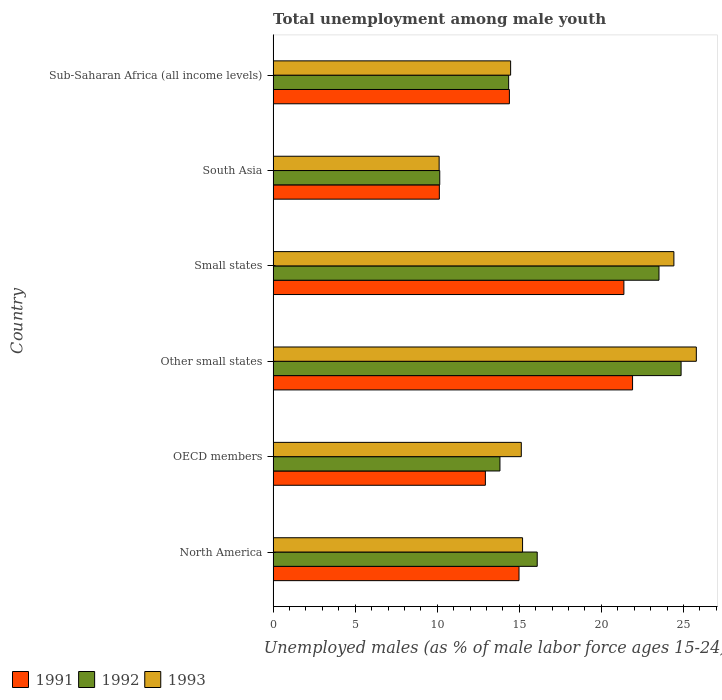How many different coloured bars are there?
Your answer should be very brief. 3. How many groups of bars are there?
Give a very brief answer. 6. How many bars are there on the 3rd tick from the bottom?
Offer a very short reply. 3. What is the label of the 1st group of bars from the top?
Keep it short and to the point. Sub-Saharan Africa (all income levels). What is the percentage of unemployed males in in 1991 in OECD members?
Your response must be concise. 12.93. Across all countries, what is the maximum percentage of unemployed males in in 1993?
Offer a very short reply. 25.79. Across all countries, what is the minimum percentage of unemployed males in in 1993?
Keep it short and to the point. 10.12. In which country was the percentage of unemployed males in in 1991 maximum?
Give a very brief answer. Other small states. In which country was the percentage of unemployed males in in 1991 minimum?
Your answer should be compact. South Asia. What is the total percentage of unemployed males in in 1993 in the graph?
Your answer should be compact. 105.11. What is the difference between the percentage of unemployed males in in 1991 in North America and that in Other small states?
Give a very brief answer. -6.92. What is the difference between the percentage of unemployed males in in 1991 in North America and the percentage of unemployed males in in 1993 in Other small states?
Offer a very short reply. -10.8. What is the average percentage of unemployed males in in 1992 per country?
Your answer should be very brief. 17.13. What is the difference between the percentage of unemployed males in in 1993 and percentage of unemployed males in in 1991 in Sub-Saharan Africa (all income levels)?
Give a very brief answer. 0.08. What is the ratio of the percentage of unemployed males in in 1992 in South Asia to that in Sub-Saharan Africa (all income levels)?
Offer a terse response. 0.71. Is the percentage of unemployed males in in 1993 in OECD members less than that in Small states?
Give a very brief answer. Yes. Is the difference between the percentage of unemployed males in in 1993 in OECD members and Small states greater than the difference between the percentage of unemployed males in in 1991 in OECD members and Small states?
Ensure brevity in your answer.  No. What is the difference between the highest and the second highest percentage of unemployed males in in 1991?
Provide a succinct answer. 0.53. What is the difference between the highest and the lowest percentage of unemployed males in in 1993?
Offer a very short reply. 15.67. In how many countries, is the percentage of unemployed males in in 1991 greater than the average percentage of unemployed males in in 1991 taken over all countries?
Ensure brevity in your answer.  2. How many bars are there?
Give a very brief answer. 18. What is the difference between two consecutive major ticks on the X-axis?
Make the answer very short. 5. How are the legend labels stacked?
Your response must be concise. Horizontal. What is the title of the graph?
Make the answer very short. Total unemployment among male youth. Does "1974" appear as one of the legend labels in the graph?
Give a very brief answer. No. What is the label or title of the X-axis?
Your answer should be compact. Unemployed males (as % of male labor force ages 15-24). What is the label or title of the Y-axis?
Offer a terse response. Country. What is the Unemployed males (as % of male labor force ages 15-24) of 1991 in North America?
Offer a terse response. 14.98. What is the Unemployed males (as % of male labor force ages 15-24) in 1992 in North America?
Offer a very short reply. 16.09. What is the Unemployed males (as % of male labor force ages 15-24) of 1993 in North America?
Offer a terse response. 15.2. What is the Unemployed males (as % of male labor force ages 15-24) in 1991 in OECD members?
Provide a succinct answer. 12.93. What is the Unemployed males (as % of male labor force ages 15-24) of 1992 in OECD members?
Offer a terse response. 13.82. What is the Unemployed males (as % of male labor force ages 15-24) of 1993 in OECD members?
Provide a succinct answer. 15.12. What is the Unemployed males (as % of male labor force ages 15-24) in 1991 in Other small states?
Offer a very short reply. 21.9. What is the Unemployed males (as % of male labor force ages 15-24) of 1992 in Other small states?
Offer a terse response. 24.86. What is the Unemployed males (as % of male labor force ages 15-24) in 1993 in Other small states?
Your answer should be very brief. 25.79. What is the Unemployed males (as % of male labor force ages 15-24) in 1991 in Small states?
Your response must be concise. 21.37. What is the Unemployed males (as % of male labor force ages 15-24) of 1992 in Small states?
Your answer should be compact. 23.51. What is the Unemployed males (as % of male labor force ages 15-24) in 1993 in Small states?
Ensure brevity in your answer.  24.42. What is the Unemployed males (as % of male labor force ages 15-24) of 1991 in South Asia?
Give a very brief answer. 10.13. What is the Unemployed males (as % of male labor force ages 15-24) in 1992 in South Asia?
Ensure brevity in your answer.  10.15. What is the Unemployed males (as % of male labor force ages 15-24) of 1993 in South Asia?
Make the answer very short. 10.12. What is the Unemployed males (as % of male labor force ages 15-24) in 1991 in Sub-Saharan Africa (all income levels)?
Your answer should be compact. 14.4. What is the Unemployed males (as % of male labor force ages 15-24) of 1992 in Sub-Saharan Africa (all income levels)?
Give a very brief answer. 14.35. What is the Unemployed males (as % of male labor force ages 15-24) in 1993 in Sub-Saharan Africa (all income levels)?
Your answer should be compact. 14.47. Across all countries, what is the maximum Unemployed males (as % of male labor force ages 15-24) of 1991?
Your response must be concise. 21.9. Across all countries, what is the maximum Unemployed males (as % of male labor force ages 15-24) of 1992?
Your answer should be very brief. 24.86. Across all countries, what is the maximum Unemployed males (as % of male labor force ages 15-24) of 1993?
Keep it short and to the point. 25.79. Across all countries, what is the minimum Unemployed males (as % of male labor force ages 15-24) in 1991?
Offer a terse response. 10.13. Across all countries, what is the minimum Unemployed males (as % of male labor force ages 15-24) of 1992?
Provide a succinct answer. 10.15. Across all countries, what is the minimum Unemployed males (as % of male labor force ages 15-24) of 1993?
Keep it short and to the point. 10.12. What is the total Unemployed males (as % of male labor force ages 15-24) of 1991 in the graph?
Ensure brevity in your answer.  95.71. What is the total Unemployed males (as % of male labor force ages 15-24) in 1992 in the graph?
Your response must be concise. 102.78. What is the total Unemployed males (as % of male labor force ages 15-24) in 1993 in the graph?
Give a very brief answer. 105.11. What is the difference between the Unemployed males (as % of male labor force ages 15-24) of 1991 in North America and that in OECD members?
Provide a short and direct response. 2.05. What is the difference between the Unemployed males (as % of male labor force ages 15-24) of 1992 in North America and that in OECD members?
Provide a short and direct response. 2.27. What is the difference between the Unemployed males (as % of male labor force ages 15-24) in 1993 in North America and that in OECD members?
Your answer should be very brief. 0.08. What is the difference between the Unemployed males (as % of male labor force ages 15-24) in 1991 in North America and that in Other small states?
Offer a terse response. -6.92. What is the difference between the Unemployed males (as % of male labor force ages 15-24) of 1992 in North America and that in Other small states?
Give a very brief answer. -8.77. What is the difference between the Unemployed males (as % of male labor force ages 15-24) in 1993 in North America and that in Other small states?
Provide a succinct answer. -10.59. What is the difference between the Unemployed males (as % of male labor force ages 15-24) in 1991 in North America and that in Small states?
Offer a very short reply. -6.39. What is the difference between the Unemployed males (as % of male labor force ages 15-24) in 1992 in North America and that in Small states?
Offer a very short reply. -7.42. What is the difference between the Unemployed males (as % of male labor force ages 15-24) in 1993 in North America and that in Small states?
Offer a terse response. -9.22. What is the difference between the Unemployed males (as % of male labor force ages 15-24) in 1991 in North America and that in South Asia?
Your answer should be very brief. 4.85. What is the difference between the Unemployed males (as % of male labor force ages 15-24) in 1992 in North America and that in South Asia?
Give a very brief answer. 5.94. What is the difference between the Unemployed males (as % of male labor force ages 15-24) of 1993 in North America and that in South Asia?
Give a very brief answer. 5.08. What is the difference between the Unemployed males (as % of male labor force ages 15-24) in 1991 in North America and that in Sub-Saharan Africa (all income levels)?
Ensure brevity in your answer.  0.59. What is the difference between the Unemployed males (as % of male labor force ages 15-24) in 1992 in North America and that in Sub-Saharan Africa (all income levels)?
Provide a short and direct response. 1.74. What is the difference between the Unemployed males (as % of male labor force ages 15-24) of 1993 in North America and that in Sub-Saharan Africa (all income levels)?
Provide a succinct answer. 0.73. What is the difference between the Unemployed males (as % of male labor force ages 15-24) of 1991 in OECD members and that in Other small states?
Offer a terse response. -8.97. What is the difference between the Unemployed males (as % of male labor force ages 15-24) in 1992 in OECD members and that in Other small states?
Keep it short and to the point. -11.04. What is the difference between the Unemployed males (as % of male labor force ages 15-24) in 1993 in OECD members and that in Other small states?
Offer a very short reply. -10.66. What is the difference between the Unemployed males (as % of male labor force ages 15-24) in 1991 in OECD members and that in Small states?
Offer a very short reply. -8.44. What is the difference between the Unemployed males (as % of male labor force ages 15-24) of 1992 in OECD members and that in Small states?
Give a very brief answer. -9.69. What is the difference between the Unemployed males (as % of male labor force ages 15-24) of 1993 in OECD members and that in Small states?
Provide a short and direct response. -9.3. What is the difference between the Unemployed males (as % of male labor force ages 15-24) in 1991 in OECD members and that in South Asia?
Make the answer very short. 2.8. What is the difference between the Unemployed males (as % of male labor force ages 15-24) in 1992 in OECD members and that in South Asia?
Your answer should be very brief. 3.67. What is the difference between the Unemployed males (as % of male labor force ages 15-24) in 1993 in OECD members and that in South Asia?
Provide a succinct answer. 5.01. What is the difference between the Unemployed males (as % of male labor force ages 15-24) in 1991 in OECD members and that in Sub-Saharan Africa (all income levels)?
Keep it short and to the point. -1.46. What is the difference between the Unemployed males (as % of male labor force ages 15-24) in 1992 in OECD members and that in Sub-Saharan Africa (all income levels)?
Your answer should be very brief. -0.53. What is the difference between the Unemployed males (as % of male labor force ages 15-24) in 1993 in OECD members and that in Sub-Saharan Africa (all income levels)?
Your answer should be very brief. 0.65. What is the difference between the Unemployed males (as % of male labor force ages 15-24) in 1991 in Other small states and that in Small states?
Your answer should be compact. 0.53. What is the difference between the Unemployed males (as % of male labor force ages 15-24) in 1992 in Other small states and that in Small states?
Keep it short and to the point. 1.35. What is the difference between the Unemployed males (as % of male labor force ages 15-24) in 1993 in Other small states and that in Small states?
Provide a succinct answer. 1.37. What is the difference between the Unemployed males (as % of male labor force ages 15-24) in 1991 in Other small states and that in South Asia?
Your answer should be very brief. 11.77. What is the difference between the Unemployed males (as % of male labor force ages 15-24) of 1992 in Other small states and that in South Asia?
Provide a short and direct response. 14.7. What is the difference between the Unemployed males (as % of male labor force ages 15-24) in 1993 in Other small states and that in South Asia?
Your response must be concise. 15.67. What is the difference between the Unemployed males (as % of male labor force ages 15-24) of 1991 in Other small states and that in Sub-Saharan Africa (all income levels)?
Your answer should be very brief. 7.5. What is the difference between the Unemployed males (as % of male labor force ages 15-24) of 1992 in Other small states and that in Sub-Saharan Africa (all income levels)?
Your answer should be compact. 10.51. What is the difference between the Unemployed males (as % of male labor force ages 15-24) of 1993 in Other small states and that in Sub-Saharan Africa (all income levels)?
Your answer should be very brief. 11.31. What is the difference between the Unemployed males (as % of male labor force ages 15-24) of 1991 in Small states and that in South Asia?
Your answer should be very brief. 11.24. What is the difference between the Unemployed males (as % of male labor force ages 15-24) of 1992 in Small states and that in South Asia?
Offer a very short reply. 13.36. What is the difference between the Unemployed males (as % of male labor force ages 15-24) of 1993 in Small states and that in South Asia?
Offer a terse response. 14.3. What is the difference between the Unemployed males (as % of male labor force ages 15-24) in 1991 in Small states and that in Sub-Saharan Africa (all income levels)?
Keep it short and to the point. 6.98. What is the difference between the Unemployed males (as % of male labor force ages 15-24) in 1992 in Small states and that in Sub-Saharan Africa (all income levels)?
Your answer should be compact. 9.16. What is the difference between the Unemployed males (as % of male labor force ages 15-24) in 1993 in Small states and that in Sub-Saharan Africa (all income levels)?
Provide a short and direct response. 9.95. What is the difference between the Unemployed males (as % of male labor force ages 15-24) of 1991 in South Asia and that in Sub-Saharan Africa (all income levels)?
Provide a short and direct response. -4.27. What is the difference between the Unemployed males (as % of male labor force ages 15-24) in 1992 in South Asia and that in Sub-Saharan Africa (all income levels)?
Your response must be concise. -4.2. What is the difference between the Unemployed males (as % of male labor force ages 15-24) in 1993 in South Asia and that in Sub-Saharan Africa (all income levels)?
Your answer should be very brief. -4.36. What is the difference between the Unemployed males (as % of male labor force ages 15-24) in 1991 in North America and the Unemployed males (as % of male labor force ages 15-24) in 1992 in OECD members?
Ensure brevity in your answer.  1.16. What is the difference between the Unemployed males (as % of male labor force ages 15-24) of 1991 in North America and the Unemployed males (as % of male labor force ages 15-24) of 1993 in OECD members?
Your answer should be very brief. -0.14. What is the difference between the Unemployed males (as % of male labor force ages 15-24) in 1992 in North America and the Unemployed males (as % of male labor force ages 15-24) in 1993 in OECD members?
Offer a terse response. 0.97. What is the difference between the Unemployed males (as % of male labor force ages 15-24) in 1991 in North America and the Unemployed males (as % of male labor force ages 15-24) in 1992 in Other small states?
Offer a very short reply. -9.88. What is the difference between the Unemployed males (as % of male labor force ages 15-24) in 1991 in North America and the Unemployed males (as % of male labor force ages 15-24) in 1993 in Other small states?
Offer a terse response. -10.8. What is the difference between the Unemployed males (as % of male labor force ages 15-24) of 1992 in North America and the Unemployed males (as % of male labor force ages 15-24) of 1993 in Other small states?
Offer a very short reply. -9.69. What is the difference between the Unemployed males (as % of male labor force ages 15-24) of 1991 in North America and the Unemployed males (as % of male labor force ages 15-24) of 1992 in Small states?
Offer a terse response. -8.53. What is the difference between the Unemployed males (as % of male labor force ages 15-24) in 1991 in North America and the Unemployed males (as % of male labor force ages 15-24) in 1993 in Small states?
Provide a short and direct response. -9.44. What is the difference between the Unemployed males (as % of male labor force ages 15-24) of 1992 in North America and the Unemployed males (as % of male labor force ages 15-24) of 1993 in Small states?
Make the answer very short. -8.33. What is the difference between the Unemployed males (as % of male labor force ages 15-24) of 1991 in North America and the Unemployed males (as % of male labor force ages 15-24) of 1992 in South Asia?
Provide a succinct answer. 4.83. What is the difference between the Unemployed males (as % of male labor force ages 15-24) in 1991 in North America and the Unemployed males (as % of male labor force ages 15-24) in 1993 in South Asia?
Your answer should be compact. 4.87. What is the difference between the Unemployed males (as % of male labor force ages 15-24) in 1992 in North America and the Unemployed males (as % of male labor force ages 15-24) in 1993 in South Asia?
Offer a terse response. 5.98. What is the difference between the Unemployed males (as % of male labor force ages 15-24) of 1991 in North America and the Unemployed males (as % of male labor force ages 15-24) of 1992 in Sub-Saharan Africa (all income levels)?
Provide a succinct answer. 0.63. What is the difference between the Unemployed males (as % of male labor force ages 15-24) in 1991 in North America and the Unemployed males (as % of male labor force ages 15-24) in 1993 in Sub-Saharan Africa (all income levels)?
Your answer should be compact. 0.51. What is the difference between the Unemployed males (as % of male labor force ages 15-24) of 1992 in North America and the Unemployed males (as % of male labor force ages 15-24) of 1993 in Sub-Saharan Africa (all income levels)?
Offer a terse response. 1.62. What is the difference between the Unemployed males (as % of male labor force ages 15-24) of 1991 in OECD members and the Unemployed males (as % of male labor force ages 15-24) of 1992 in Other small states?
Offer a very short reply. -11.92. What is the difference between the Unemployed males (as % of male labor force ages 15-24) in 1991 in OECD members and the Unemployed males (as % of male labor force ages 15-24) in 1993 in Other small states?
Provide a succinct answer. -12.85. What is the difference between the Unemployed males (as % of male labor force ages 15-24) of 1992 in OECD members and the Unemployed males (as % of male labor force ages 15-24) of 1993 in Other small states?
Keep it short and to the point. -11.97. What is the difference between the Unemployed males (as % of male labor force ages 15-24) in 1991 in OECD members and the Unemployed males (as % of male labor force ages 15-24) in 1992 in Small states?
Provide a succinct answer. -10.58. What is the difference between the Unemployed males (as % of male labor force ages 15-24) of 1991 in OECD members and the Unemployed males (as % of male labor force ages 15-24) of 1993 in Small states?
Your answer should be compact. -11.49. What is the difference between the Unemployed males (as % of male labor force ages 15-24) in 1992 in OECD members and the Unemployed males (as % of male labor force ages 15-24) in 1993 in Small states?
Your response must be concise. -10.6. What is the difference between the Unemployed males (as % of male labor force ages 15-24) in 1991 in OECD members and the Unemployed males (as % of male labor force ages 15-24) in 1992 in South Asia?
Provide a short and direct response. 2.78. What is the difference between the Unemployed males (as % of male labor force ages 15-24) of 1991 in OECD members and the Unemployed males (as % of male labor force ages 15-24) of 1993 in South Asia?
Ensure brevity in your answer.  2.82. What is the difference between the Unemployed males (as % of male labor force ages 15-24) in 1992 in OECD members and the Unemployed males (as % of male labor force ages 15-24) in 1993 in South Asia?
Your answer should be compact. 3.7. What is the difference between the Unemployed males (as % of male labor force ages 15-24) of 1991 in OECD members and the Unemployed males (as % of male labor force ages 15-24) of 1992 in Sub-Saharan Africa (all income levels)?
Your answer should be compact. -1.42. What is the difference between the Unemployed males (as % of male labor force ages 15-24) in 1991 in OECD members and the Unemployed males (as % of male labor force ages 15-24) in 1993 in Sub-Saharan Africa (all income levels)?
Provide a succinct answer. -1.54. What is the difference between the Unemployed males (as % of male labor force ages 15-24) in 1992 in OECD members and the Unemployed males (as % of male labor force ages 15-24) in 1993 in Sub-Saharan Africa (all income levels)?
Provide a succinct answer. -0.65. What is the difference between the Unemployed males (as % of male labor force ages 15-24) of 1991 in Other small states and the Unemployed males (as % of male labor force ages 15-24) of 1992 in Small states?
Offer a terse response. -1.61. What is the difference between the Unemployed males (as % of male labor force ages 15-24) in 1991 in Other small states and the Unemployed males (as % of male labor force ages 15-24) in 1993 in Small states?
Provide a short and direct response. -2.52. What is the difference between the Unemployed males (as % of male labor force ages 15-24) of 1992 in Other small states and the Unemployed males (as % of male labor force ages 15-24) of 1993 in Small states?
Offer a very short reply. 0.44. What is the difference between the Unemployed males (as % of male labor force ages 15-24) of 1991 in Other small states and the Unemployed males (as % of male labor force ages 15-24) of 1992 in South Asia?
Your answer should be very brief. 11.75. What is the difference between the Unemployed males (as % of male labor force ages 15-24) in 1991 in Other small states and the Unemployed males (as % of male labor force ages 15-24) in 1993 in South Asia?
Provide a short and direct response. 11.78. What is the difference between the Unemployed males (as % of male labor force ages 15-24) in 1992 in Other small states and the Unemployed males (as % of male labor force ages 15-24) in 1993 in South Asia?
Your answer should be very brief. 14.74. What is the difference between the Unemployed males (as % of male labor force ages 15-24) in 1991 in Other small states and the Unemployed males (as % of male labor force ages 15-24) in 1992 in Sub-Saharan Africa (all income levels)?
Provide a succinct answer. 7.55. What is the difference between the Unemployed males (as % of male labor force ages 15-24) in 1991 in Other small states and the Unemployed males (as % of male labor force ages 15-24) in 1993 in Sub-Saharan Africa (all income levels)?
Provide a succinct answer. 7.43. What is the difference between the Unemployed males (as % of male labor force ages 15-24) in 1992 in Other small states and the Unemployed males (as % of male labor force ages 15-24) in 1993 in Sub-Saharan Africa (all income levels)?
Keep it short and to the point. 10.39. What is the difference between the Unemployed males (as % of male labor force ages 15-24) in 1991 in Small states and the Unemployed males (as % of male labor force ages 15-24) in 1992 in South Asia?
Keep it short and to the point. 11.22. What is the difference between the Unemployed males (as % of male labor force ages 15-24) of 1991 in Small states and the Unemployed males (as % of male labor force ages 15-24) of 1993 in South Asia?
Your response must be concise. 11.26. What is the difference between the Unemployed males (as % of male labor force ages 15-24) in 1992 in Small states and the Unemployed males (as % of male labor force ages 15-24) in 1993 in South Asia?
Make the answer very short. 13.39. What is the difference between the Unemployed males (as % of male labor force ages 15-24) of 1991 in Small states and the Unemployed males (as % of male labor force ages 15-24) of 1992 in Sub-Saharan Africa (all income levels)?
Keep it short and to the point. 7.02. What is the difference between the Unemployed males (as % of male labor force ages 15-24) in 1991 in Small states and the Unemployed males (as % of male labor force ages 15-24) in 1993 in Sub-Saharan Africa (all income levels)?
Offer a very short reply. 6.9. What is the difference between the Unemployed males (as % of male labor force ages 15-24) in 1992 in Small states and the Unemployed males (as % of male labor force ages 15-24) in 1993 in Sub-Saharan Africa (all income levels)?
Your response must be concise. 9.04. What is the difference between the Unemployed males (as % of male labor force ages 15-24) of 1991 in South Asia and the Unemployed males (as % of male labor force ages 15-24) of 1992 in Sub-Saharan Africa (all income levels)?
Keep it short and to the point. -4.22. What is the difference between the Unemployed males (as % of male labor force ages 15-24) in 1991 in South Asia and the Unemployed males (as % of male labor force ages 15-24) in 1993 in Sub-Saharan Africa (all income levels)?
Offer a terse response. -4.34. What is the difference between the Unemployed males (as % of male labor force ages 15-24) of 1992 in South Asia and the Unemployed males (as % of male labor force ages 15-24) of 1993 in Sub-Saharan Africa (all income levels)?
Give a very brief answer. -4.32. What is the average Unemployed males (as % of male labor force ages 15-24) of 1991 per country?
Offer a very short reply. 15.95. What is the average Unemployed males (as % of male labor force ages 15-24) in 1992 per country?
Keep it short and to the point. 17.13. What is the average Unemployed males (as % of male labor force ages 15-24) of 1993 per country?
Keep it short and to the point. 17.52. What is the difference between the Unemployed males (as % of male labor force ages 15-24) of 1991 and Unemployed males (as % of male labor force ages 15-24) of 1992 in North America?
Your response must be concise. -1.11. What is the difference between the Unemployed males (as % of male labor force ages 15-24) in 1991 and Unemployed males (as % of male labor force ages 15-24) in 1993 in North America?
Your answer should be compact. -0.22. What is the difference between the Unemployed males (as % of male labor force ages 15-24) in 1992 and Unemployed males (as % of male labor force ages 15-24) in 1993 in North America?
Offer a terse response. 0.89. What is the difference between the Unemployed males (as % of male labor force ages 15-24) of 1991 and Unemployed males (as % of male labor force ages 15-24) of 1992 in OECD members?
Keep it short and to the point. -0.89. What is the difference between the Unemployed males (as % of male labor force ages 15-24) of 1991 and Unemployed males (as % of male labor force ages 15-24) of 1993 in OECD members?
Provide a succinct answer. -2.19. What is the difference between the Unemployed males (as % of male labor force ages 15-24) in 1992 and Unemployed males (as % of male labor force ages 15-24) in 1993 in OECD members?
Ensure brevity in your answer.  -1.3. What is the difference between the Unemployed males (as % of male labor force ages 15-24) in 1991 and Unemployed males (as % of male labor force ages 15-24) in 1992 in Other small states?
Your response must be concise. -2.96. What is the difference between the Unemployed males (as % of male labor force ages 15-24) of 1991 and Unemployed males (as % of male labor force ages 15-24) of 1993 in Other small states?
Offer a terse response. -3.89. What is the difference between the Unemployed males (as % of male labor force ages 15-24) of 1992 and Unemployed males (as % of male labor force ages 15-24) of 1993 in Other small states?
Give a very brief answer. -0.93. What is the difference between the Unemployed males (as % of male labor force ages 15-24) of 1991 and Unemployed males (as % of male labor force ages 15-24) of 1992 in Small states?
Give a very brief answer. -2.14. What is the difference between the Unemployed males (as % of male labor force ages 15-24) of 1991 and Unemployed males (as % of male labor force ages 15-24) of 1993 in Small states?
Give a very brief answer. -3.05. What is the difference between the Unemployed males (as % of male labor force ages 15-24) in 1992 and Unemployed males (as % of male labor force ages 15-24) in 1993 in Small states?
Offer a very short reply. -0.91. What is the difference between the Unemployed males (as % of male labor force ages 15-24) in 1991 and Unemployed males (as % of male labor force ages 15-24) in 1992 in South Asia?
Your answer should be compact. -0.02. What is the difference between the Unemployed males (as % of male labor force ages 15-24) of 1991 and Unemployed males (as % of male labor force ages 15-24) of 1993 in South Asia?
Make the answer very short. 0.01. What is the difference between the Unemployed males (as % of male labor force ages 15-24) of 1992 and Unemployed males (as % of male labor force ages 15-24) of 1993 in South Asia?
Give a very brief answer. 0.04. What is the difference between the Unemployed males (as % of male labor force ages 15-24) of 1991 and Unemployed males (as % of male labor force ages 15-24) of 1992 in Sub-Saharan Africa (all income levels)?
Your answer should be very brief. 0.05. What is the difference between the Unemployed males (as % of male labor force ages 15-24) of 1991 and Unemployed males (as % of male labor force ages 15-24) of 1993 in Sub-Saharan Africa (all income levels)?
Provide a short and direct response. -0.08. What is the difference between the Unemployed males (as % of male labor force ages 15-24) of 1992 and Unemployed males (as % of male labor force ages 15-24) of 1993 in Sub-Saharan Africa (all income levels)?
Give a very brief answer. -0.12. What is the ratio of the Unemployed males (as % of male labor force ages 15-24) in 1991 in North America to that in OECD members?
Provide a short and direct response. 1.16. What is the ratio of the Unemployed males (as % of male labor force ages 15-24) in 1992 in North America to that in OECD members?
Give a very brief answer. 1.16. What is the ratio of the Unemployed males (as % of male labor force ages 15-24) of 1993 in North America to that in OECD members?
Keep it short and to the point. 1.01. What is the ratio of the Unemployed males (as % of male labor force ages 15-24) in 1991 in North America to that in Other small states?
Provide a short and direct response. 0.68. What is the ratio of the Unemployed males (as % of male labor force ages 15-24) in 1992 in North America to that in Other small states?
Your answer should be very brief. 0.65. What is the ratio of the Unemployed males (as % of male labor force ages 15-24) in 1993 in North America to that in Other small states?
Your response must be concise. 0.59. What is the ratio of the Unemployed males (as % of male labor force ages 15-24) of 1991 in North America to that in Small states?
Your answer should be compact. 0.7. What is the ratio of the Unemployed males (as % of male labor force ages 15-24) in 1992 in North America to that in Small states?
Offer a terse response. 0.68. What is the ratio of the Unemployed males (as % of male labor force ages 15-24) in 1993 in North America to that in Small states?
Your answer should be compact. 0.62. What is the ratio of the Unemployed males (as % of male labor force ages 15-24) of 1991 in North America to that in South Asia?
Make the answer very short. 1.48. What is the ratio of the Unemployed males (as % of male labor force ages 15-24) in 1992 in North America to that in South Asia?
Your answer should be very brief. 1.58. What is the ratio of the Unemployed males (as % of male labor force ages 15-24) in 1993 in North America to that in South Asia?
Provide a short and direct response. 1.5. What is the ratio of the Unemployed males (as % of male labor force ages 15-24) of 1991 in North America to that in Sub-Saharan Africa (all income levels)?
Your answer should be very brief. 1.04. What is the ratio of the Unemployed males (as % of male labor force ages 15-24) of 1992 in North America to that in Sub-Saharan Africa (all income levels)?
Offer a very short reply. 1.12. What is the ratio of the Unemployed males (as % of male labor force ages 15-24) of 1993 in North America to that in Sub-Saharan Africa (all income levels)?
Give a very brief answer. 1.05. What is the ratio of the Unemployed males (as % of male labor force ages 15-24) in 1991 in OECD members to that in Other small states?
Ensure brevity in your answer.  0.59. What is the ratio of the Unemployed males (as % of male labor force ages 15-24) of 1992 in OECD members to that in Other small states?
Ensure brevity in your answer.  0.56. What is the ratio of the Unemployed males (as % of male labor force ages 15-24) of 1993 in OECD members to that in Other small states?
Ensure brevity in your answer.  0.59. What is the ratio of the Unemployed males (as % of male labor force ages 15-24) in 1991 in OECD members to that in Small states?
Provide a succinct answer. 0.61. What is the ratio of the Unemployed males (as % of male labor force ages 15-24) of 1992 in OECD members to that in Small states?
Ensure brevity in your answer.  0.59. What is the ratio of the Unemployed males (as % of male labor force ages 15-24) of 1993 in OECD members to that in Small states?
Give a very brief answer. 0.62. What is the ratio of the Unemployed males (as % of male labor force ages 15-24) of 1991 in OECD members to that in South Asia?
Offer a very short reply. 1.28. What is the ratio of the Unemployed males (as % of male labor force ages 15-24) in 1992 in OECD members to that in South Asia?
Your answer should be compact. 1.36. What is the ratio of the Unemployed males (as % of male labor force ages 15-24) in 1993 in OECD members to that in South Asia?
Provide a succinct answer. 1.49. What is the ratio of the Unemployed males (as % of male labor force ages 15-24) in 1991 in OECD members to that in Sub-Saharan Africa (all income levels)?
Provide a succinct answer. 0.9. What is the ratio of the Unemployed males (as % of male labor force ages 15-24) of 1992 in OECD members to that in Sub-Saharan Africa (all income levels)?
Make the answer very short. 0.96. What is the ratio of the Unemployed males (as % of male labor force ages 15-24) in 1993 in OECD members to that in Sub-Saharan Africa (all income levels)?
Provide a short and direct response. 1.04. What is the ratio of the Unemployed males (as % of male labor force ages 15-24) in 1991 in Other small states to that in Small states?
Keep it short and to the point. 1.02. What is the ratio of the Unemployed males (as % of male labor force ages 15-24) in 1992 in Other small states to that in Small states?
Make the answer very short. 1.06. What is the ratio of the Unemployed males (as % of male labor force ages 15-24) of 1993 in Other small states to that in Small states?
Ensure brevity in your answer.  1.06. What is the ratio of the Unemployed males (as % of male labor force ages 15-24) in 1991 in Other small states to that in South Asia?
Your response must be concise. 2.16. What is the ratio of the Unemployed males (as % of male labor force ages 15-24) in 1992 in Other small states to that in South Asia?
Your answer should be very brief. 2.45. What is the ratio of the Unemployed males (as % of male labor force ages 15-24) of 1993 in Other small states to that in South Asia?
Keep it short and to the point. 2.55. What is the ratio of the Unemployed males (as % of male labor force ages 15-24) of 1991 in Other small states to that in Sub-Saharan Africa (all income levels)?
Offer a terse response. 1.52. What is the ratio of the Unemployed males (as % of male labor force ages 15-24) of 1992 in Other small states to that in Sub-Saharan Africa (all income levels)?
Your answer should be very brief. 1.73. What is the ratio of the Unemployed males (as % of male labor force ages 15-24) in 1993 in Other small states to that in Sub-Saharan Africa (all income levels)?
Offer a very short reply. 1.78. What is the ratio of the Unemployed males (as % of male labor force ages 15-24) in 1991 in Small states to that in South Asia?
Keep it short and to the point. 2.11. What is the ratio of the Unemployed males (as % of male labor force ages 15-24) in 1992 in Small states to that in South Asia?
Your answer should be very brief. 2.32. What is the ratio of the Unemployed males (as % of male labor force ages 15-24) in 1993 in Small states to that in South Asia?
Your response must be concise. 2.41. What is the ratio of the Unemployed males (as % of male labor force ages 15-24) in 1991 in Small states to that in Sub-Saharan Africa (all income levels)?
Ensure brevity in your answer.  1.48. What is the ratio of the Unemployed males (as % of male labor force ages 15-24) in 1992 in Small states to that in Sub-Saharan Africa (all income levels)?
Make the answer very short. 1.64. What is the ratio of the Unemployed males (as % of male labor force ages 15-24) of 1993 in Small states to that in Sub-Saharan Africa (all income levels)?
Your response must be concise. 1.69. What is the ratio of the Unemployed males (as % of male labor force ages 15-24) in 1991 in South Asia to that in Sub-Saharan Africa (all income levels)?
Keep it short and to the point. 0.7. What is the ratio of the Unemployed males (as % of male labor force ages 15-24) in 1992 in South Asia to that in Sub-Saharan Africa (all income levels)?
Provide a succinct answer. 0.71. What is the ratio of the Unemployed males (as % of male labor force ages 15-24) of 1993 in South Asia to that in Sub-Saharan Africa (all income levels)?
Make the answer very short. 0.7. What is the difference between the highest and the second highest Unemployed males (as % of male labor force ages 15-24) in 1991?
Your response must be concise. 0.53. What is the difference between the highest and the second highest Unemployed males (as % of male labor force ages 15-24) in 1992?
Provide a short and direct response. 1.35. What is the difference between the highest and the second highest Unemployed males (as % of male labor force ages 15-24) in 1993?
Offer a terse response. 1.37. What is the difference between the highest and the lowest Unemployed males (as % of male labor force ages 15-24) of 1991?
Your answer should be very brief. 11.77. What is the difference between the highest and the lowest Unemployed males (as % of male labor force ages 15-24) of 1992?
Offer a terse response. 14.7. What is the difference between the highest and the lowest Unemployed males (as % of male labor force ages 15-24) in 1993?
Keep it short and to the point. 15.67. 